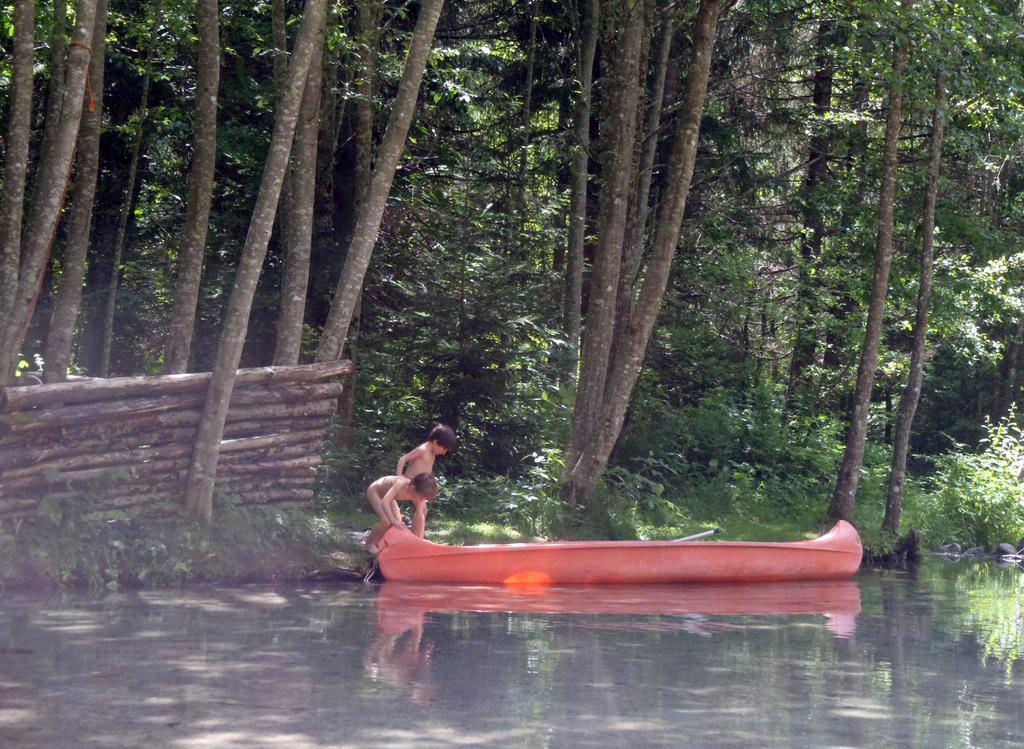Can you describe this image briefly? In the foreground of this picture, there is a boat on the water and there are two boys standing beside the boat. In the background, there are sticks, trees, plants and the grass. 